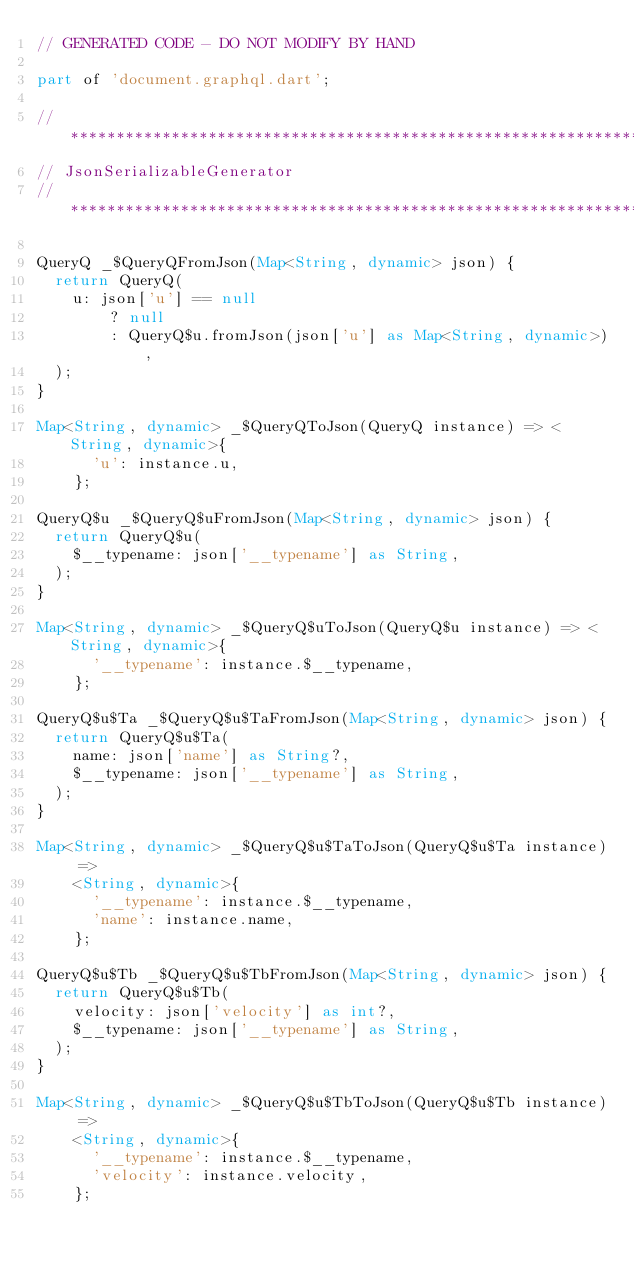<code> <loc_0><loc_0><loc_500><loc_500><_Dart_>// GENERATED CODE - DO NOT MODIFY BY HAND

part of 'document.graphql.dart';

// **************************************************************************
// JsonSerializableGenerator
// **************************************************************************

QueryQ _$QueryQFromJson(Map<String, dynamic> json) {
  return QueryQ(
    u: json['u'] == null
        ? null
        : QueryQ$u.fromJson(json['u'] as Map<String, dynamic>),
  );
}

Map<String, dynamic> _$QueryQToJson(QueryQ instance) => <String, dynamic>{
      'u': instance.u,
    };

QueryQ$u _$QueryQ$uFromJson(Map<String, dynamic> json) {
  return QueryQ$u(
    $__typename: json['__typename'] as String,
  );
}

Map<String, dynamic> _$QueryQ$uToJson(QueryQ$u instance) => <String, dynamic>{
      '__typename': instance.$__typename,
    };

QueryQ$u$Ta _$QueryQ$u$TaFromJson(Map<String, dynamic> json) {
  return QueryQ$u$Ta(
    name: json['name'] as String?,
    $__typename: json['__typename'] as String,
  );
}

Map<String, dynamic> _$QueryQ$u$TaToJson(QueryQ$u$Ta instance) =>
    <String, dynamic>{
      '__typename': instance.$__typename,
      'name': instance.name,
    };

QueryQ$u$Tb _$QueryQ$u$TbFromJson(Map<String, dynamic> json) {
  return QueryQ$u$Tb(
    velocity: json['velocity'] as int?,
    $__typename: json['__typename'] as String,
  );
}

Map<String, dynamic> _$QueryQ$u$TbToJson(QueryQ$u$Tb instance) =>
    <String, dynamic>{
      '__typename': instance.$__typename,
      'velocity': instance.velocity,
    };
</code> 